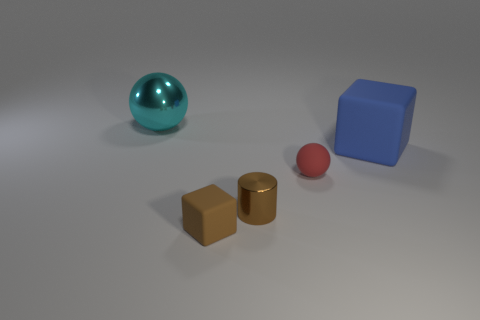How many matte things are small red spheres or big blue cubes?
Offer a very short reply. 2. Is the number of large cyan objects in front of the small red object the same as the number of yellow blocks?
Provide a short and direct response. Yes. There is a tiny matte object that is to the right of the brown cylinder; is its color the same as the big matte thing?
Ensure brevity in your answer.  No. There is a thing that is to the left of the brown shiny cylinder and on the right side of the large cyan sphere; what material is it made of?
Keep it short and to the point. Rubber. Is there a small brown metallic cylinder that is on the left side of the rubber thing that is to the left of the small ball?
Offer a terse response. No. Does the tiny cube have the same material as the big cyan thing?
Offer a terse response. No. The thing that is both to the left of the tiny red rubber sphere and behind the red rubber object has what shape?
Offer a terse response. Sphere. There is a brown rubber block in front of the matte block that is behind the brown matte object; how big is it?
Your response must be concise. Small. How many tiny things have the same shape as the big cyan object?
Provide a succinct answer. 1. Is the color of the cylinder the same as the large sphere?
Your answer should be very brief. No. 